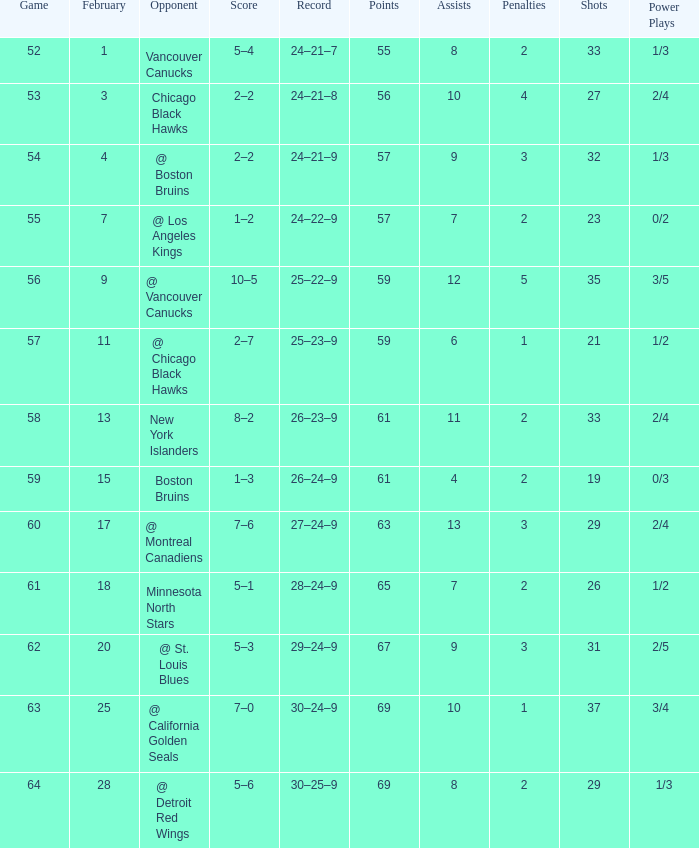Which opponent has a game larger than 61, february smaller than 28, and fewer points than 69? @ St. Louis Blues. 